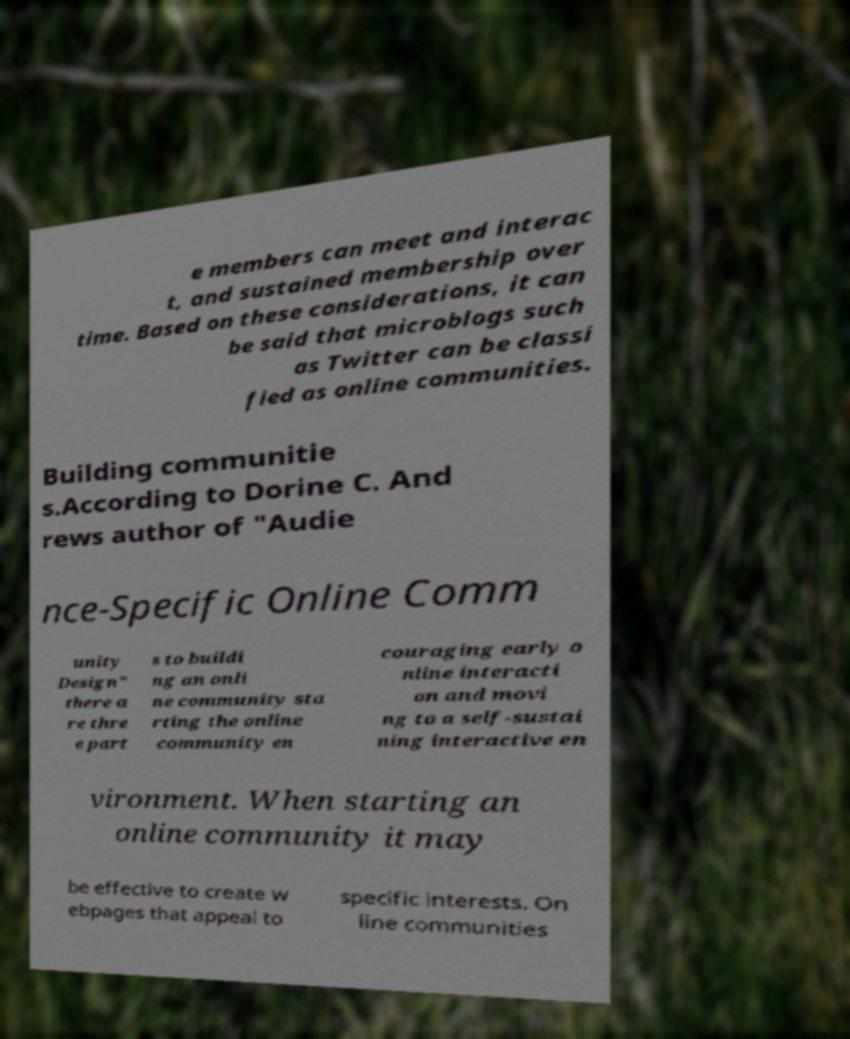Could you assist in decoding the text presented in this image and type it out clearly? e members can meet and interac t, and sustained membership over time. Based on these considerations, it can be said that microblogs such as Twitter can be classi fied as online communities. Building communitie s.According to Dorine C. And rews author of "Audie nce-Specific Online Comm unity Design" there a re thre e part s to buildi ng an onli ne community sta rting the online community en couraging early o nline interacti on and movi ng to a self-sustai ning interactive en vironment. When starting an online community it may be effective to create w ebpages that appeal to specific interests. On line communities 